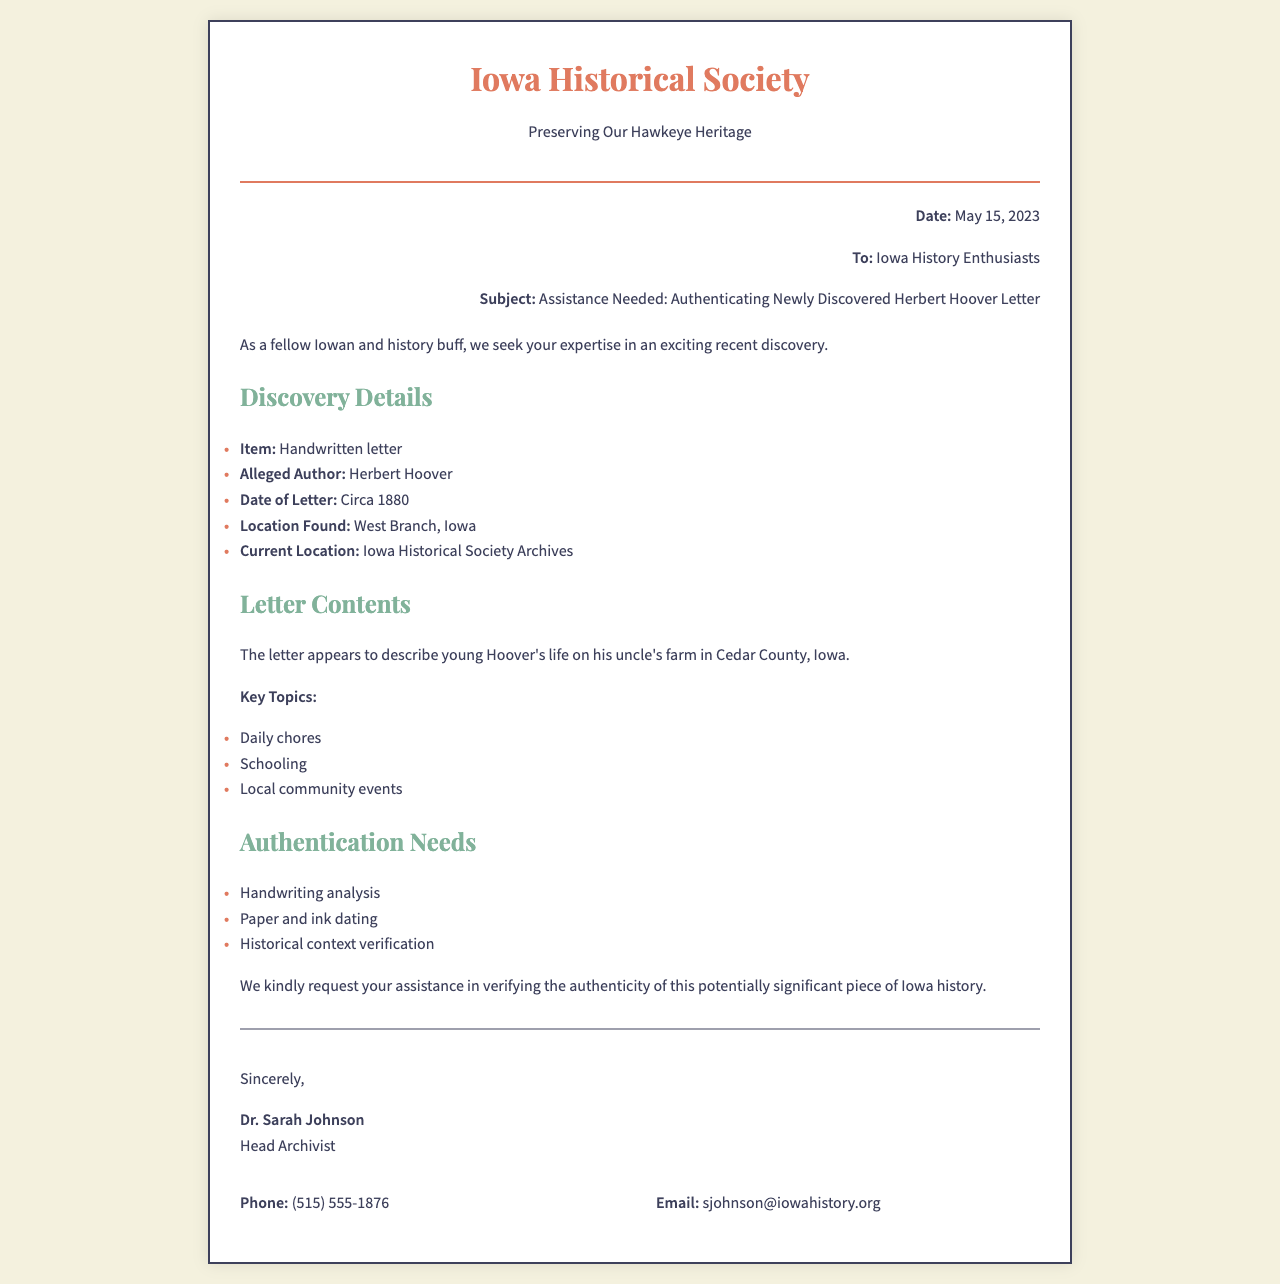What is the date of the fax? The date of the fax is stated at the top right corner of the document.
Answer: May 15, 2023 Who is the sender of the fax? The sender's name is mentioned in the signature section of the document.
Answer: Dr. Sarah Johnson What does the letter describe? The content of the letter is summarized in the section discussing its themes and topics.
Answer: Young Hoover's life on his uncle's farm Where was the letter found? The location where the letter was discovered is listed in the discovery details.
Answer: West Branch, Iowa What authentication needs are mentioned? The document outlines specific needs for authentication in a list format.
Answer: Handwriting analysis What key topics are discussed in the letter? The topics are listed in the section detailing the contents of the letter.
Answer: Daily chores, Schooling, Local community events What organization is seeking assistance? The name of the organization is mentioned in the header of the document.
Answer: Iowa Historical Society What is the contact phone number provided? The phone number is listed in the contact information section.
Answer: (515) 555-1876 